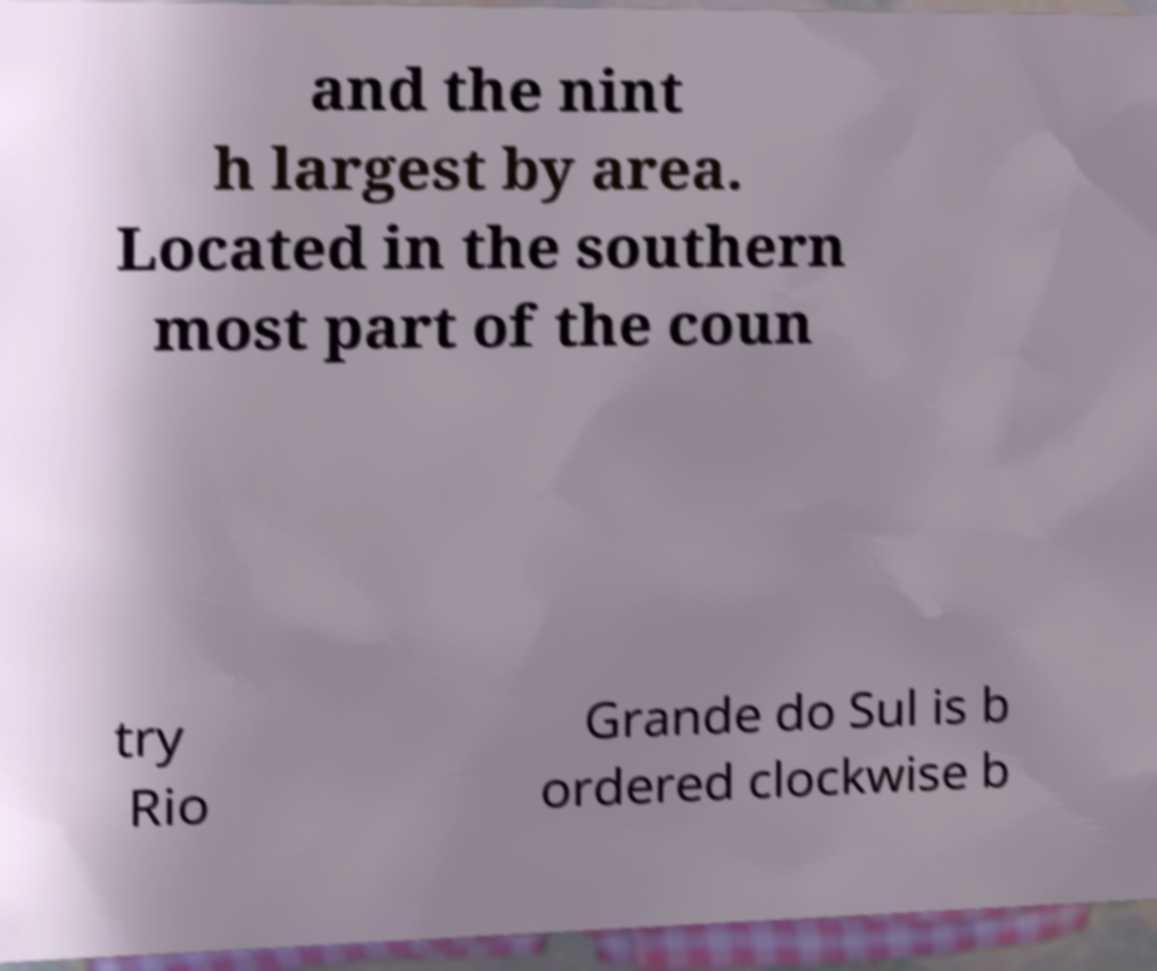There's text embedded in this image that I need extracted. Can you transcribe it verbatim? and the nint h largest by area. Located in the southern most part of the coun try Rio Grande do Sul is b ordered clockwise b 